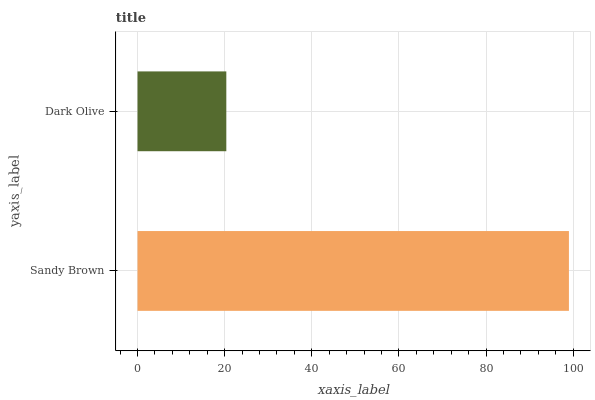Is Dark Olive the minimum?
Answer yes or no. Yes. Is Sandy Brown the maximum?
Answer yes or no. Yes. Is Dark Olive the maximum?
Answer yes or no. No. Is Sandy Brown greater than Dark Olive?
Answer yes or no. Yes. Is Dark Olive less than Sandy Brown?
Answer yes or no. Yes. Is Dark Olive greater than Sandy Brown?
Answer yes or no. No. Is Sandy Brown less than Dark Olive?
Answer yes or no. No. Is Sandy Brown the high median?
Answer yes or no. Yes. Is Dark Olive the low median?
Answer yes or no. Yes. Is Dark Olive the high median?
Answer yes or no. No. Is Sandy Brown the low median?
Answer yes or no. No. 